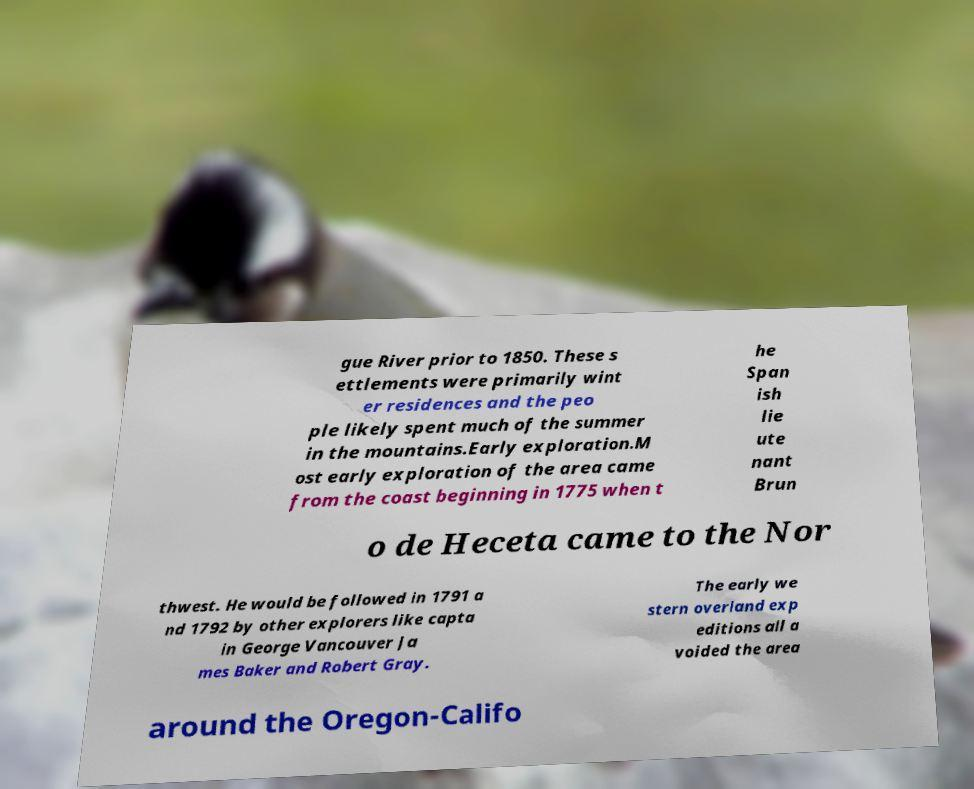What messages or text are displayed in this image? I need them in a readable, typed format. gue River prior to 1850. These s ettlements were primarily wint er residences and the peo ple likely spent much of the summer in the mountains.Early exploration.M ost early exploration of the area came from the coast beginning in 1775 when t he Span ish lie ute nant Brun o de Heceta came to the Nor thwest. He would be followed in 1791 a nd 1792 by other explorers like capta in George Vancouver Ja mes Baker and Robert Gray. The early we stern overland exp editions all a voided the area around the Oregon-Califo 